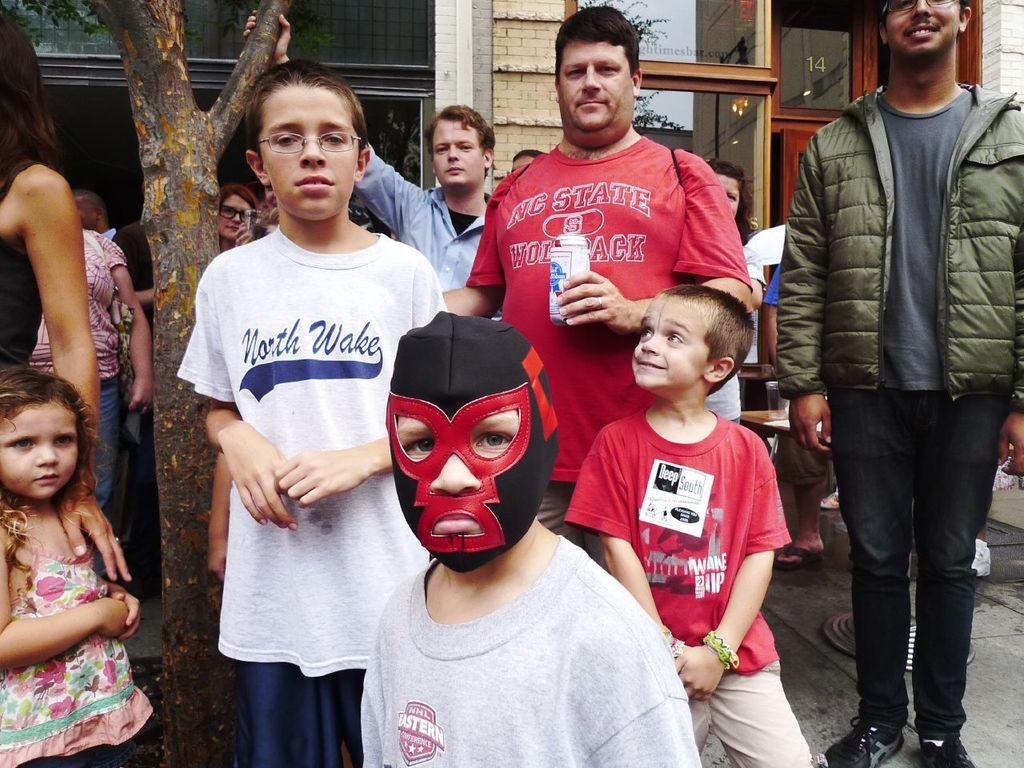What are the people in the image doing? The persons standing on the ground are likely engaged in an activity or standing together. What is the child wearing that is visible in the image? The child is wearing a red and black colored mask. What type of natural element can be seen in the image? There is a tree in the image. What type of man-made structure is visible in the background? There is a building in the background of the image. What historical event is being commemorated by the persons in the image? There is no indication of a historical event being commemorated in the image. Can you tell me how many times the tree has been burned in the image? There is no evidence of the tree being burned in the image. 